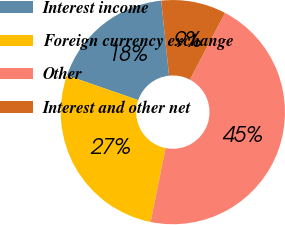Convert chart to OTSL. <chart><loc_0><loc_0><loc_500><loc_500><pie_chart><fcel>Interest income<fcel>Foreign currency exchange<fcel>Other<fcel>Interest and other net<nl><fcel>18.03%<fcel>27.14%<fcel>45.48%<fcel>9.36%<nl></chart> 